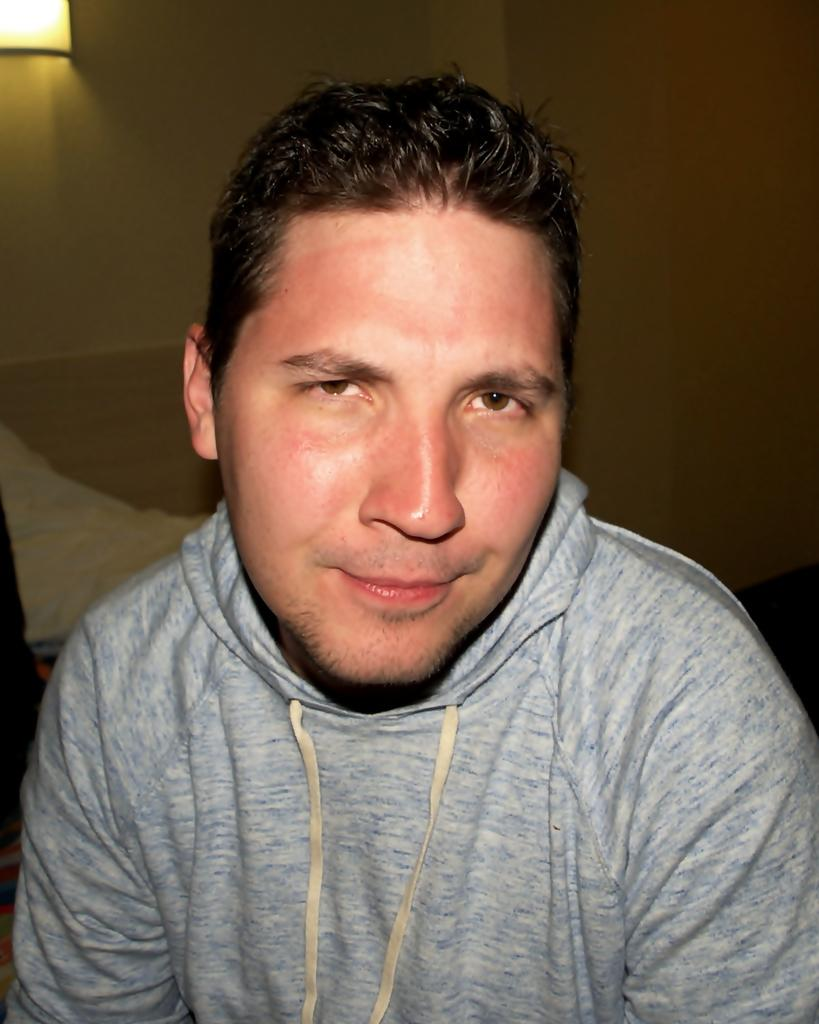Who is present in the image? There is a man in the image. What can be seen in the background of the image? There is an object in the background of the image. What type of lighting is present in the image? There is a light on the wall in the image. What type of soup is the man eating in the image? There is no soup present in the image; the man is not eating anything. 